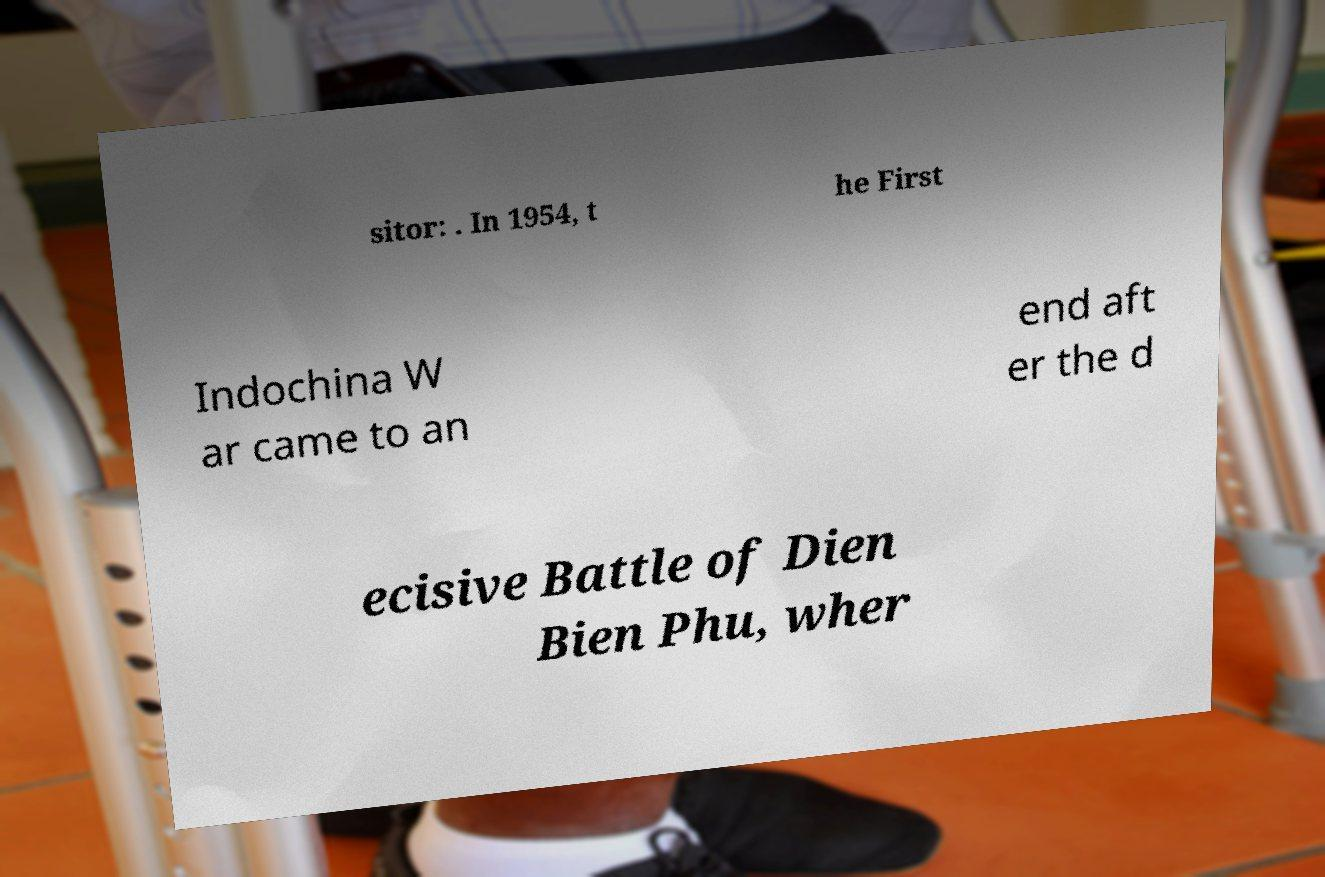Please identify and transcribe the text found in this image. sitor: . In 1954, t he First Indochina W ar came to an end aft er the d ecisive Battle of Dien Bien Phu, wher 